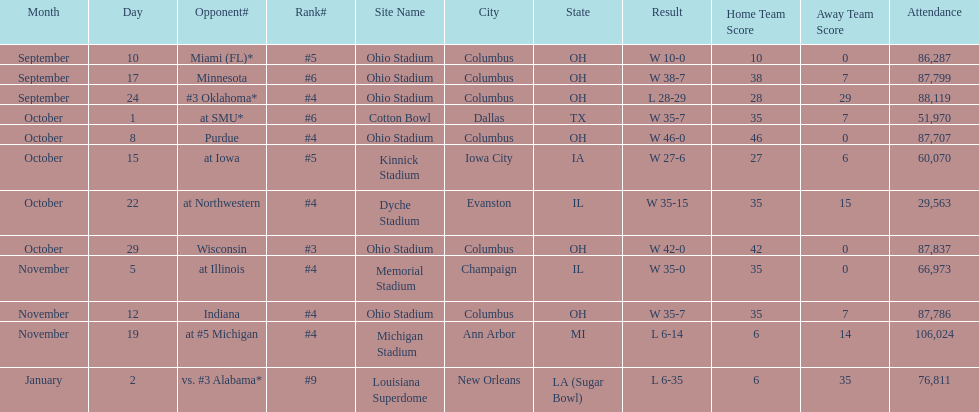What is the difference between the number of wins and the number of losses? 6. 